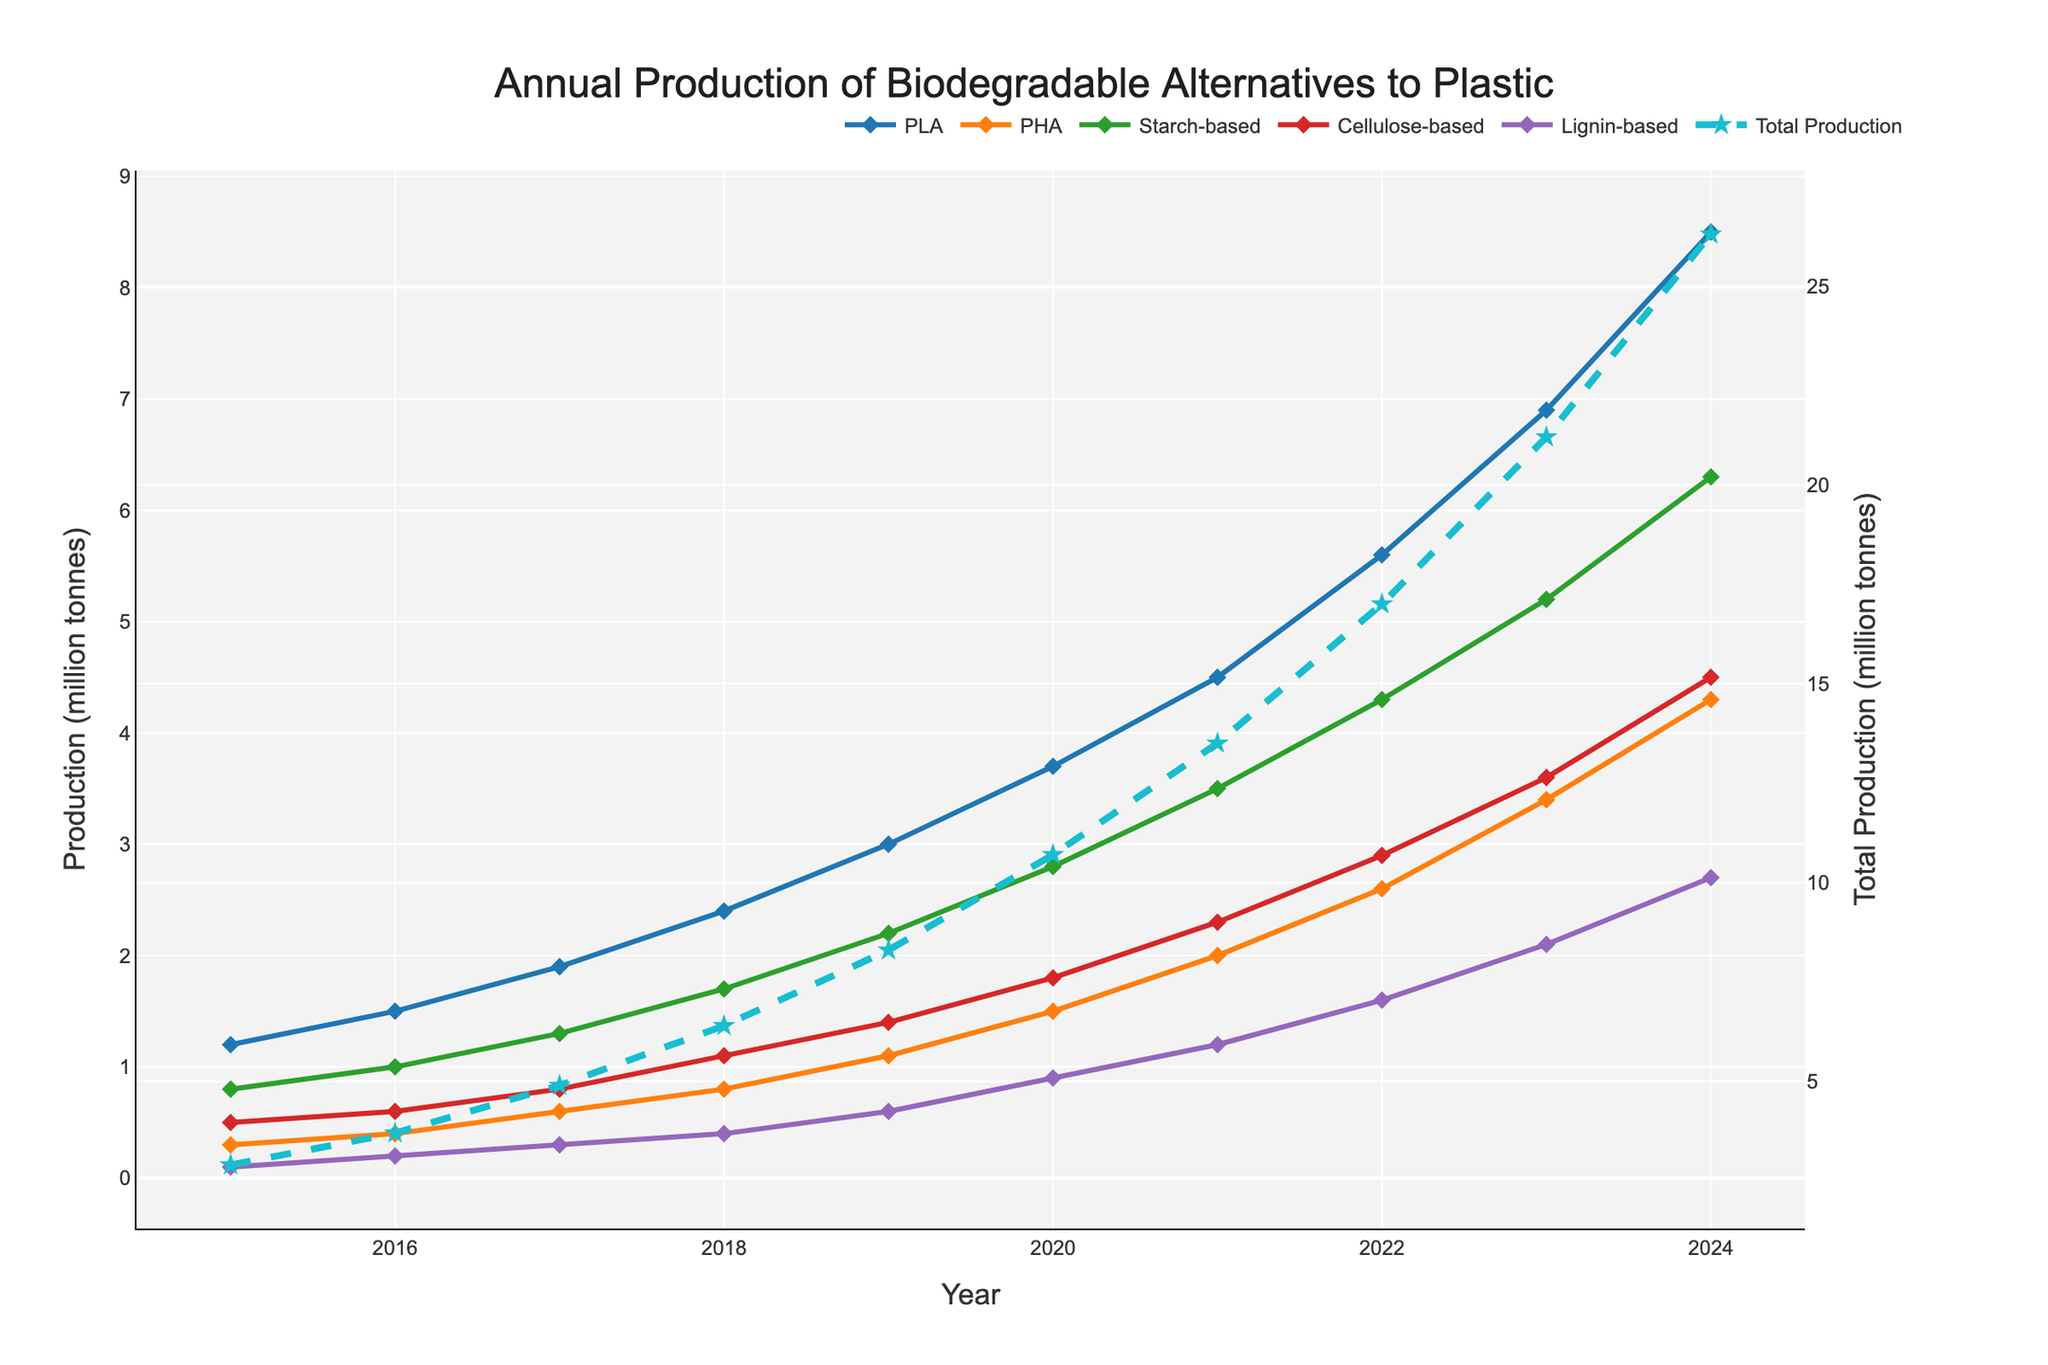Which material had the highest production in 2023? Compare the points on the line chart for each material in 2023. PLA is the highest at 6.9 million tonnes.
Answer: PLA How much did the total production increase from 2020 to 2021? Look at the "Total Production" line and find the values for 2020 and 2021. The total production in 2020 is 9.7 million tonnes and in 2021 is 13.5 million tonnes. Subtract 9.7 from 13.5 to get a difference of 3.8 million tonnes.
Answer: 3.8 million tonnes What was the trend of starch-based material production between 2017 and 2019? Observe the direction of the starch-based line (green) in the given years. It is increasing from 1.3 in 2017 to 2.2 in 2019.
Answer: Increasing Which material showed the least production in 2015? Compare the points on the line chart for each material in 2015. Lignin-based is the lowest at 0.1 million tonnes.
Answer: Lignin-based Did any material surpass 4 million tonnes in production before 2023? Check each material's line and see when they first exceed 4 million tonnes. PLA surpassed 4 million tonnes in 2021.
Answer: Yes, PLA in 2021 What was the total production of biodegradable alternatives to plastic in 2024? Look at the "Total Production" line (dashed line with stars) for 2024. The total production is 25.3 million tonnes.
Answer: 25.3 million tonnes Between 2015 and 2024, which material had the largest absolute increase in production? Compare the starting and ending points for each material line. PLA increased from 1.2 in 2015 to 8.5 in 2024, an absolute increase of 7.3 million tonnes.
Answer: PLA By how much did cellulose-based production grow from 2019 to 2024? Observe the points for cellulose-based (purple) at 2019 and 2024. The production in 2019 is 1.4 million tonnes and in 2024 is 4.5 million tonnes. Subtract 1.4 from 4.5 to get a difference of 3.1 million tonnes.
Answer: 3.1 million tonnes Which year's total production crossed the 10 million tonnes mark for the first time? Follow the "Total Production" line to see when it first surpasses 10 million tonnes. It occurs in 2020.
Answer: 2020 How did the production of PHA in 2021 compare to its production in 2019? Compare the points on the line for PHA in both years. PHA increased from 1.1 in 2019 to 2.0 in 2021.
Answer: Increased 